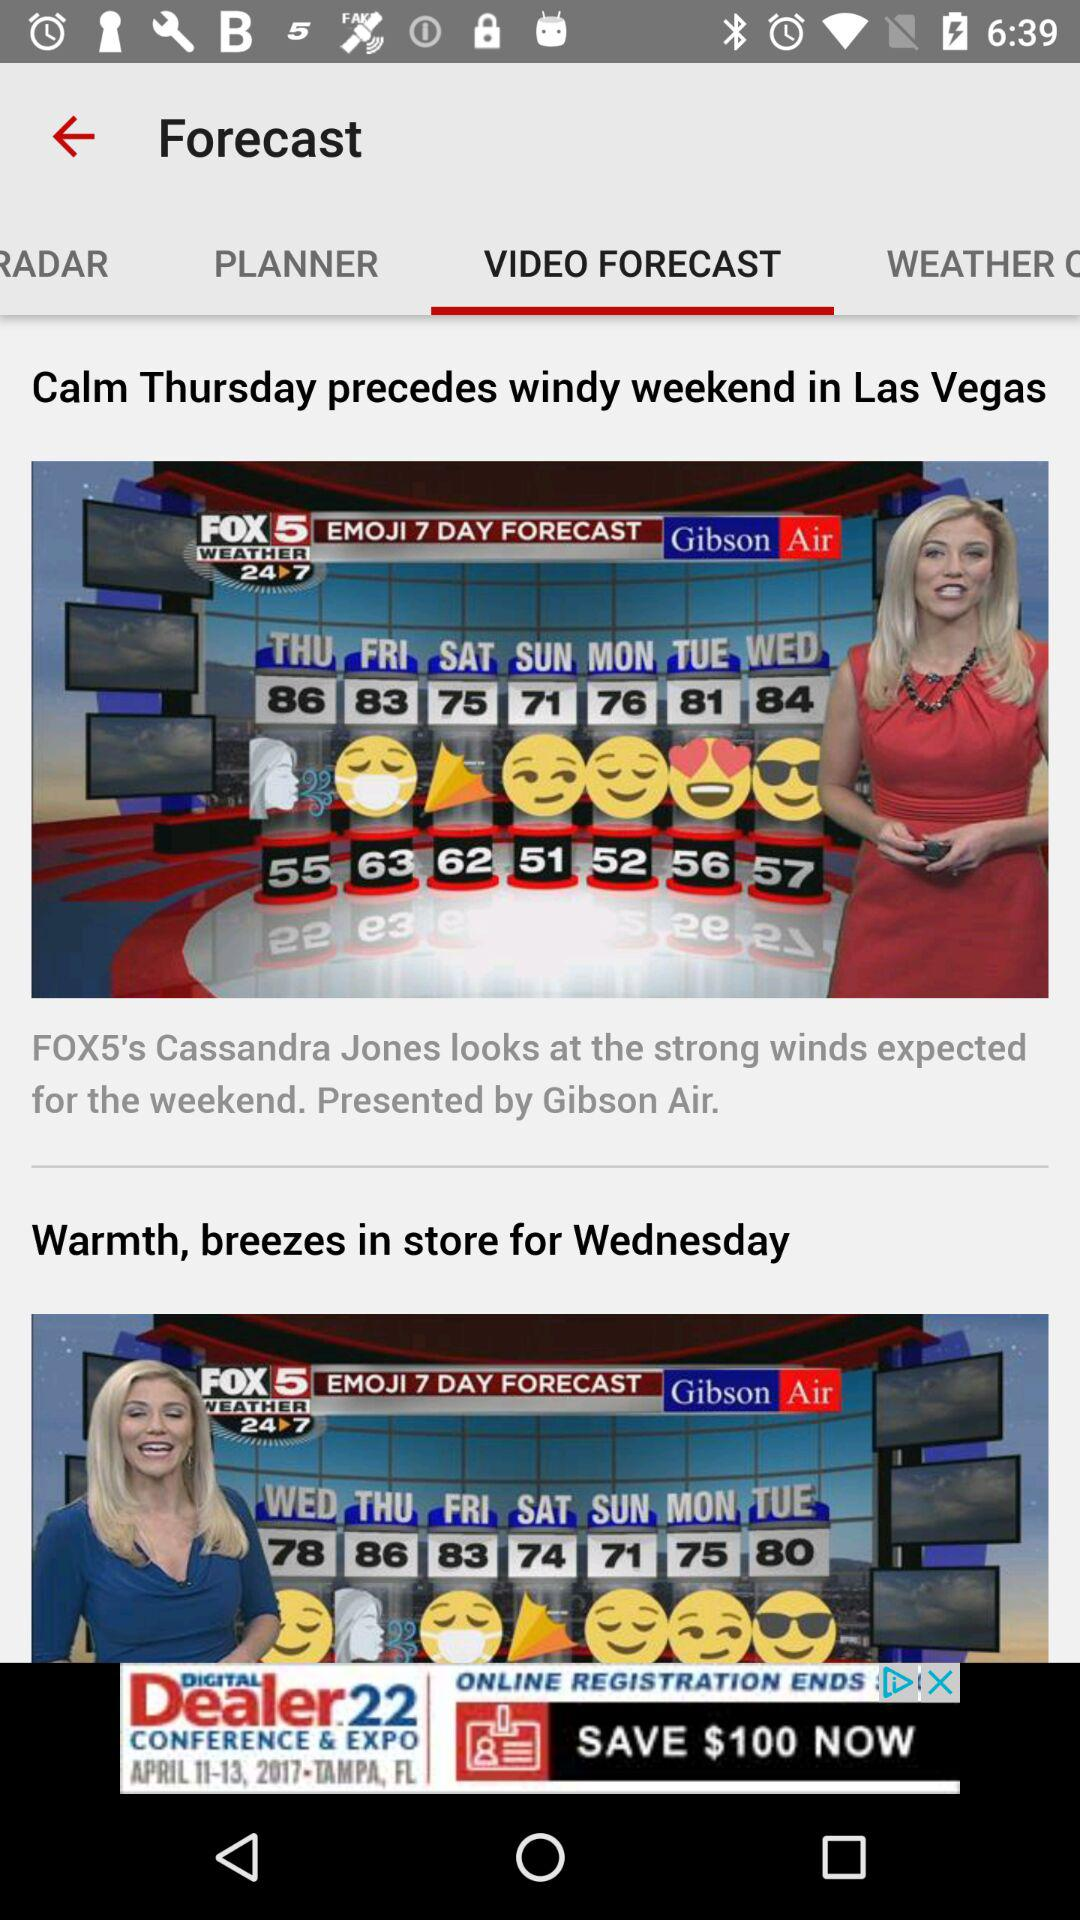Which tab is selected? The selected tab is "VIDEO FORECAST". 